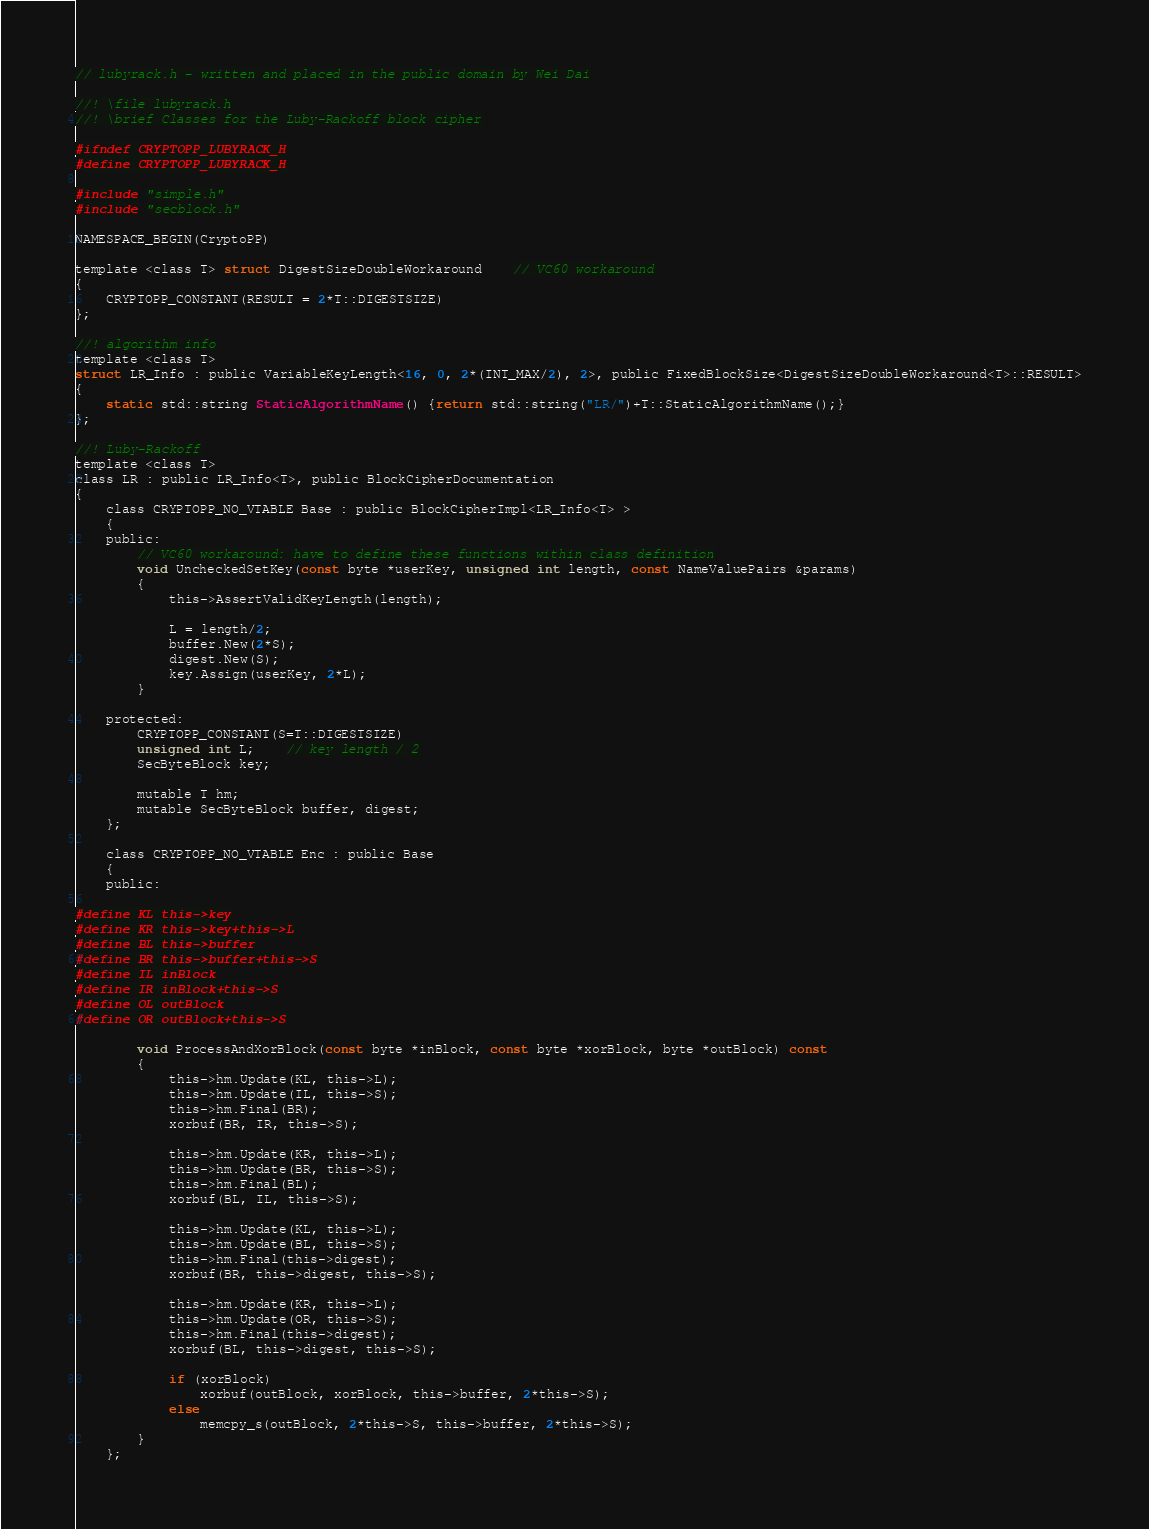<code> <loc_0><loc_0><loc_500><loc_500><_C_>// lubyrack.h - written and placed in the public domain by Wei Dai

//! \file lubyrack.h
//! \brief Classes for the Luby-Rackoff block cipher
	
#ifndef CRYPTOPP_LUBYRACK_H
#define CRYPTOPP_LUBYRACK_H

#include "simple.h"
#include "secblock.h"

NAMESPACE_BEGIN(CryptoPP)

template <class T> struct DigestSizeDoubleWorkaround 	// VC60 workaround
{
	CRYPTOPP_CONSTANT(RESULT = 2*T::DIGESTSIZE)
};

//! algorithm info
template <class T>
struct LR_Info : public VariableKeyLength<16, 0, 2*(INT_MAX/2), 2>, public FixedBlockSize<DigestSizeDoubleWorkaround<T>::RESULT>
{
	static std::string StaticAlgorithmName() {return std::string("LR/")+T::StaticAlgorithmName();}
};

//! Luby-Rackoff
template <class T>
class LR : public LR_Info<T>, public BlockCipherDocumentation
{
	class CRYPTOPP_NO_VTABLE Base : public BlockCipherImpl<LR_Info<T> >
	{
	public:
		// VC60 workaround: have to define these functions within class definition
		void UncheckedSetKey(const byte *userKey, unsigned int length, const NameValuePairs &params)
		{
			this->AssertValidKeyLength(length);

			L = length/2;
			buffer.New(2*S);
			digest.New(S);
			key.Assign(userKey, 2*L);
		}

	protected:
		CRYPTOPP_CONSTANT(S=T::DIGESTSIZE)
		unsigned int L;	// key length / 2
		SecByteBlock key;

		mutable T hm;
		mutable SecByteBlock buffer, digest;
	};

	class CRYPTOPP_NO_VTABLE Enc : public Base
	{
	public:

#define KL this->key
#define KR this->key+this->L
#define BL this->buffer
#define BR this->buffer+this->S
#define IL inBlock
#define IR inBlock+this->S
#define OL outBlock
#define OR outBlock+this->S

		void ProcessAndXorBlock(const byte *inBlock, const byte *xorBlock, byte *outBlock) const
		{
			this->hm.Update(KL, this->L);
			this->hm.Update(IL, this->S);
			this->hm.Final(BR);
			xorbuf(BR, IR, this->S);

			this->hm.Update(KR, this->L);
			this->hm.Update(BR, this->S);
			this->hm.Final(BL);
			xorbuf(BL, IL, this->S);

			this->hm.Update(KL, this->L);
			this->hm.Update(BL, this->S);
			this->hm.Final(this->digest);
			xorbuf(BR, this->digest, this->S);

			this->hm.Update(KR, this->L);
			this->hm.Update(OR, this->S);
			this->hm.Final(this->digest);
			xorbuf(BL, this->digest, this->S);

			if (xorBlock)
				xorbuf(outBlock, xorBlock, this->buffer, 2*this->S);
			else
				memcpy_s(outBlock, 2*this->S, this->buffer, 2*this->S);
		}
	};
</code> 